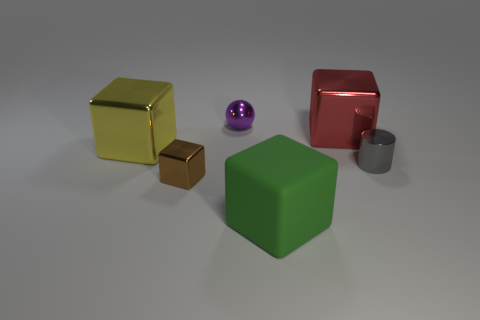How many brown metal blocks have the same size as the green rubber block?
Your response must be concise. 0. There is a big metal cube right of the shiny thing behind the red cube; what is its color?
Your answer should be very brief. Red. What color is the sphere that is the same size as the brown metallic thing?
Keep it short and to the point. Purple. Do the tiny thing that is right of the red cube and the tiny purple ball have the same material?
Offer a terse response. Yes. Is there a cube that is on the left side of the big shiny object left of the large shiny thing on the right side of the purple metallic sphere?
Give a very brief answer. No. There is a large metallic thing on the right side of the brown metal cube; is its shape the same as the brown metallic thing?
Provide a succinct answer. Yes. There is a tiny shiny thing behind the big metallic object to the right of the purple metal sphere; what shape is it?
Your answer should be compact. Sphere. There is a sphere that is on the left side of the large block that is in front of the small metal object right of the green rubber thing; how big is it?
Offer a very short reply. Small. There is another big shiny thing that is the same shape as the yellow shiny thing; what is its color?
Offer a terse response. Red. Is the size of the green matte thing the same as the red metal block?
Your response must be concise. Yes. 